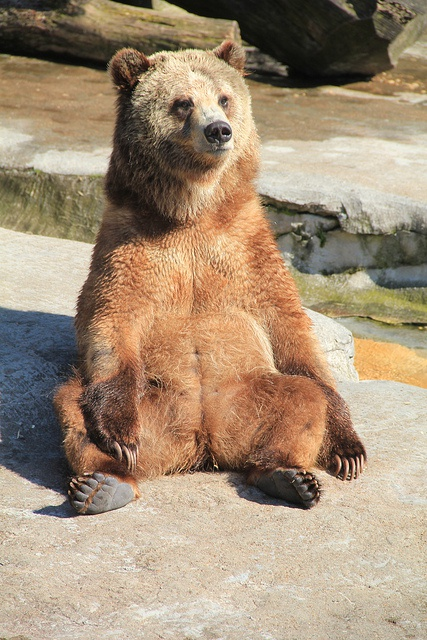Describe the objects in this image and their specific colors. I can see a bear in black, tan, and salmon tones in this image. 